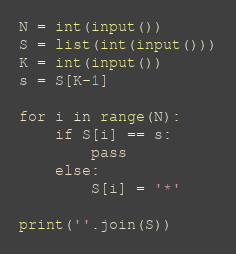Convert code to text. <code><loc_0><loc_0><loc_500><loc_500><_Python_>N = int(input())
S = list(int(input()))
K = int(input())
s = S[K-1]

for i in range(N):
    if S[i] == s:
        pass
    else:
        S[i] = '*'

print(''.join(S))

</code> 